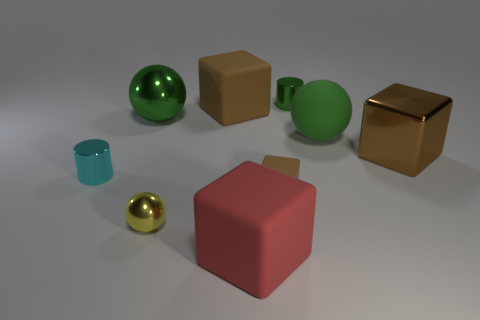Are there any tiny purple balls that have the same material as the tiny cube?
Offer a terse response. No. The big object that is the same color as the large metal sphere is what shape?
Give a very brief answer. Sphere. There is a small object that is to the right of the tiny brown rubber cube; what is its color?
Your response must be concise. Green. Are there an equal number of green rubber things in front of the large red matte object and small green cylinders in front of the large green matte thing?
Make the answer very short. Yes. What is the material of the brown object that is left of the brown rubber object that is in front of the shiny cube?
Keep it short and to the point. Rubber. How many things are either yellow cylinders or metallic balls behind the small brown matte thing?
Keep it short and to the point. 1. What is the size of the brown thing that is the same material as the yellow thing?
Your response must be concise. Large. Are there more matte balls that are in front of the small cyan metallic object than large yellow matte cylinders?
Provide a short and direct response. No. There is a metal thing that is in front of the large brown rubber cube and to the right of the big red cube; how big is it?
Give a very brief answer. Large. What material is the other tiny brown thing that is the same shape as the brown metallic thing?
Ensure brevity in your answer.  Rubber. 